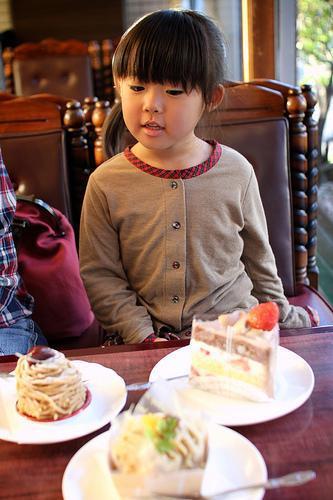How many desserts are on the table?
Give a very brief answer. 3. 